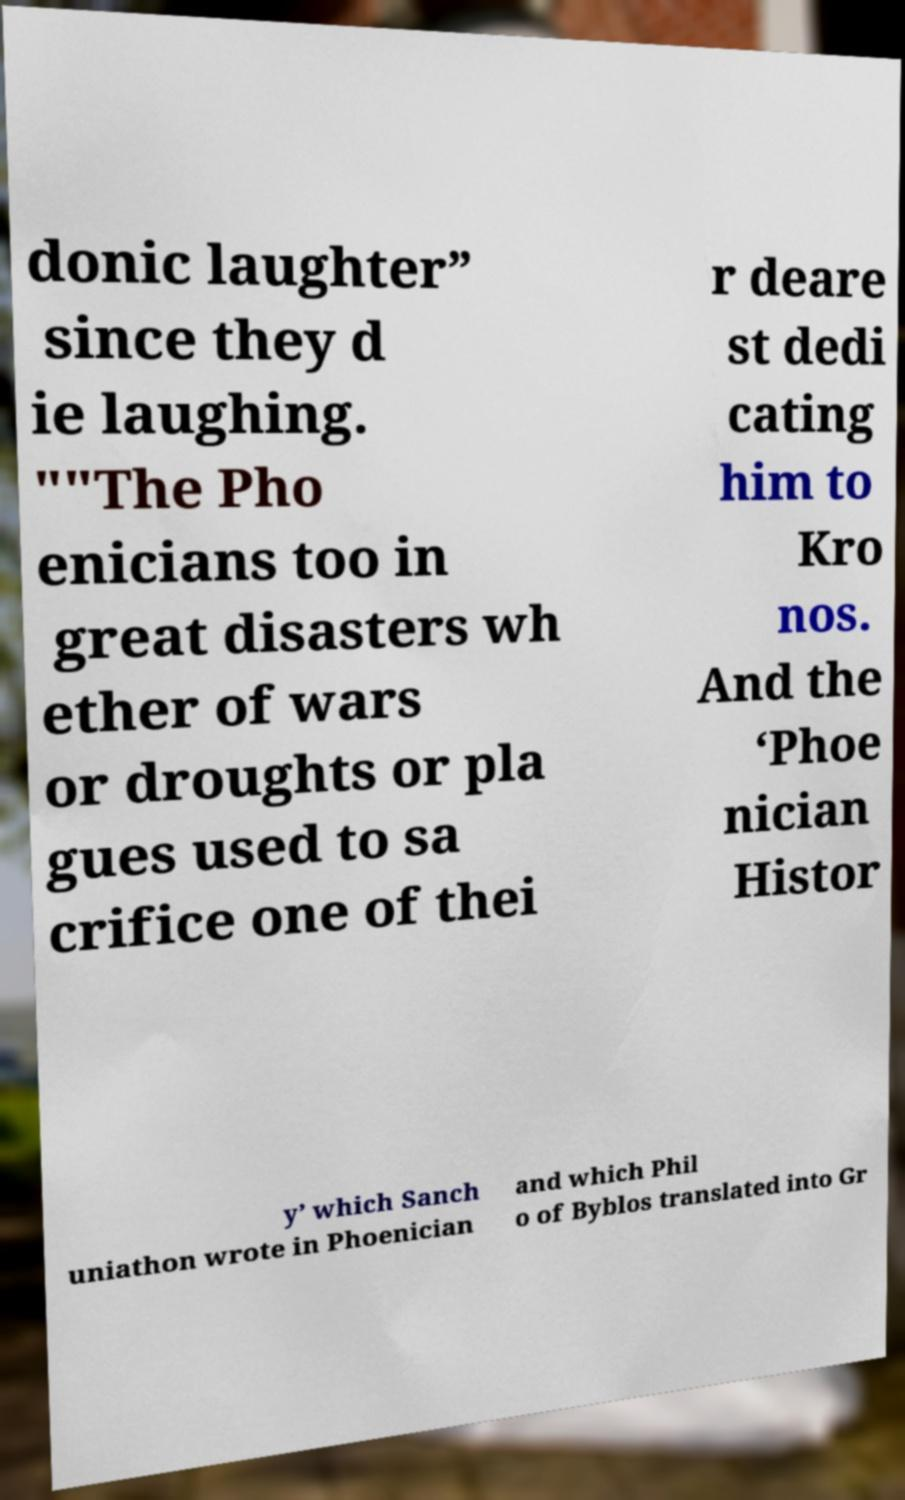Could you extract and type out the text from this image? donic laughter” since they d ie laughing. ""The Pho enicians too in great disasters wh ether of wars or droughts or pla gues used to sa crifice one of thei r deare st dedi cating him to Kro nos. And the ‘Phoe nician Histor y’ which Sanch uniathon wrote in Phoenician and which Phil o of Byblos translated into Gr 